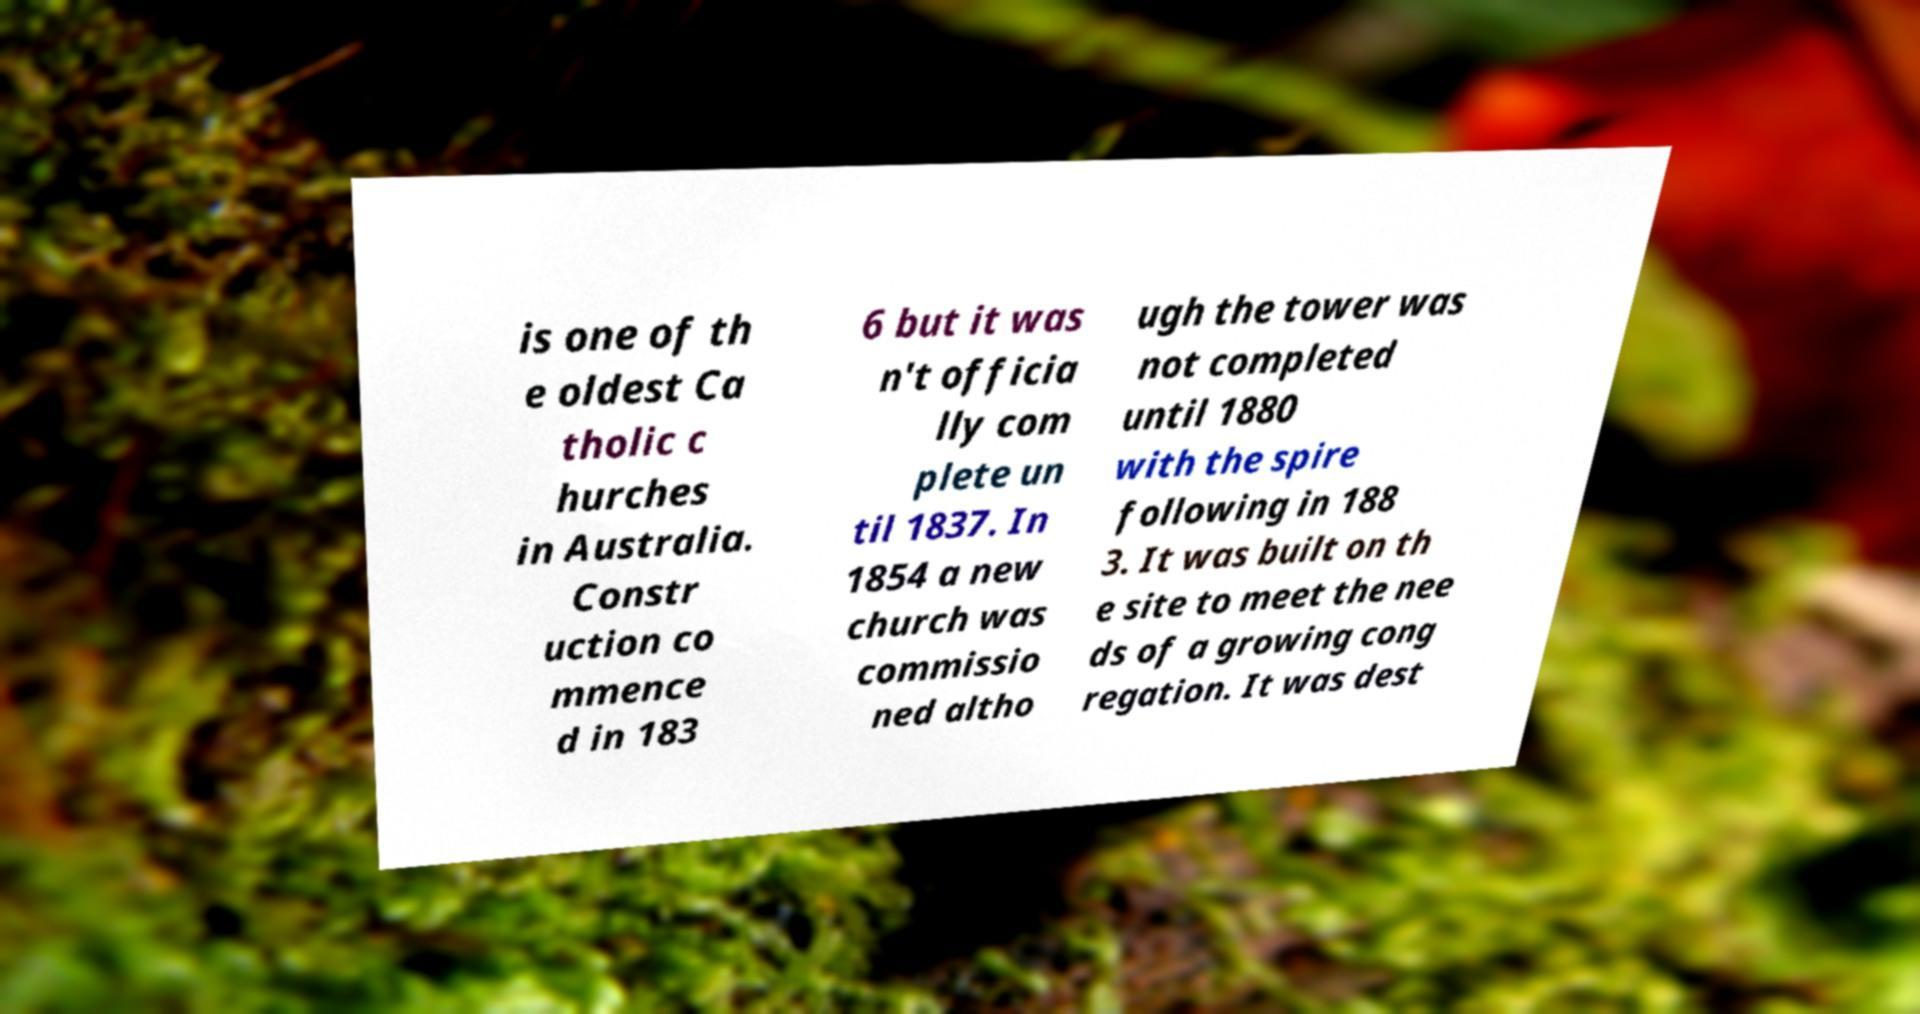Can you read and provide the text displayed in the image?This photo seems to have some interesting text. Can you extract and type it out for me? is one of th e oldest Ca tholic c hurches in Australia. Constr uction co mmence d in 183 6 but it was n't officia lly com plete un til 1837. In 1854 a new church was commissio ned altho ugh the tower was not completed until 1880 with the spire following in 188 3. It was built on th e site to meet the nee ds of a growing cong regation. It was dest 